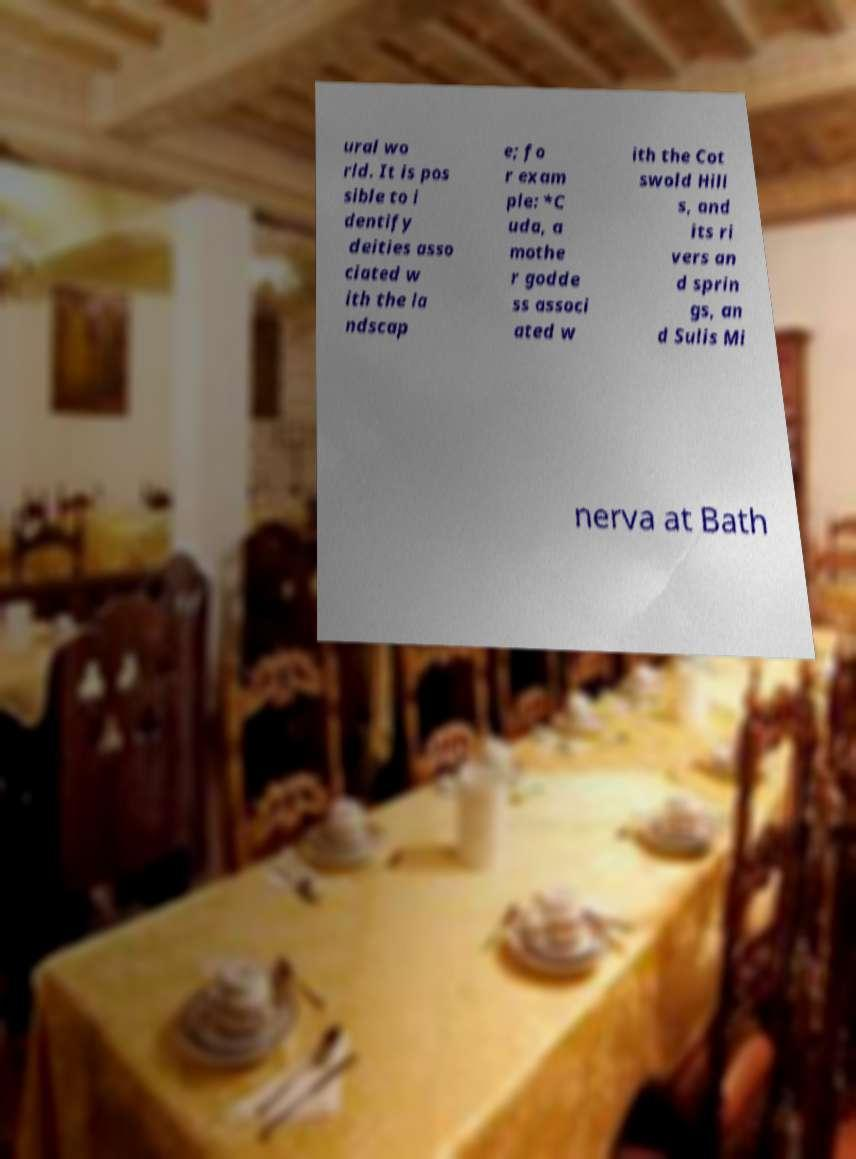For documentation purposes, I need the text within this image transcribed. Could you provide that? ural wo rld. It is pos sible to i dentify deities asso ciated w ith the la ndscap e; fo r exam ple: *C uda, a mothe r godde ss associ ated w ith the Cot swold Hill s, and its ri vers an d sprin gs, an d Sulis Mi nerva at Bath 